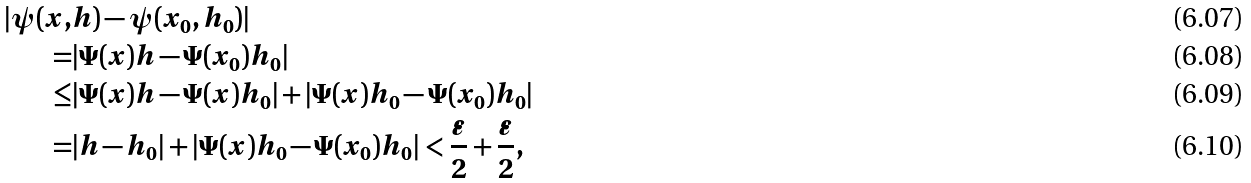<formula> <loc_0><loc_0><loc_500><loc_500>| \psi ( x , & h ) - \psi ( x _ { 0 } , h _ { 0 } ) | \\ = & | \Psi ( x ) h - \Psi ( x _ { 0 } ) h _ { 0 } | \\ \leq & | \Psi ( x ) h - \Psi ( x ) h _ { 0 } | + | \Psi ( x ) h _ { 0 } - \Psi ( x _ { 0 } ) h _ { 0 } | \\ = & | h - h _ { 0 } | + | \Psi ( x ) h _ { 0 } - \Psi ( x _ { 0 } ) h _ { 0 } | < \frac { \varepsilon } { 2 } + \frac { \varepsilon } { 2 } ,</formula> 